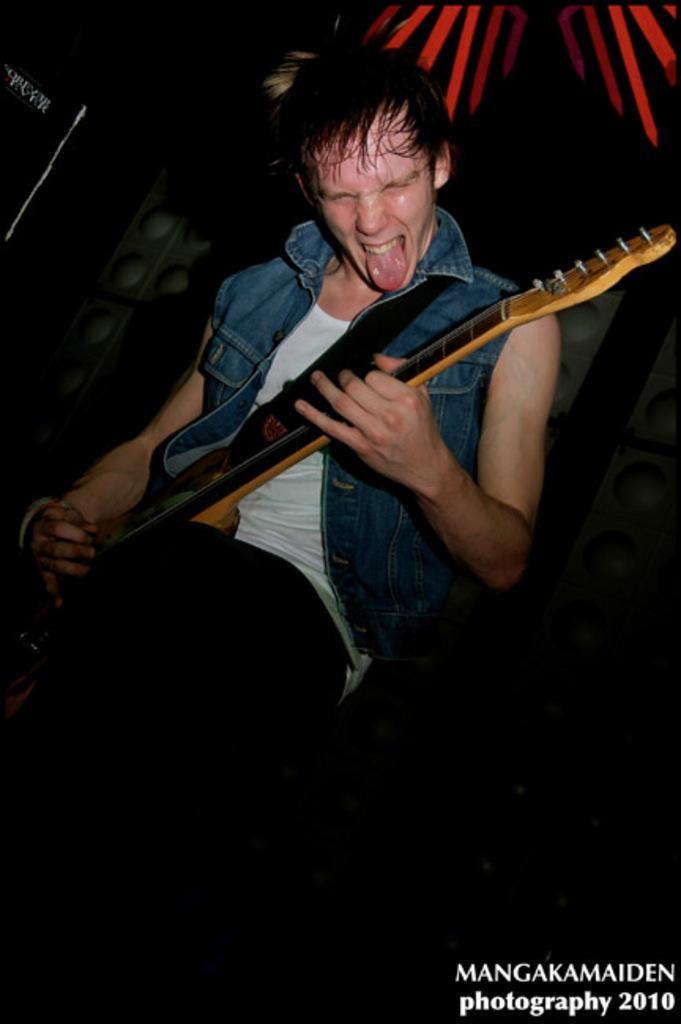Please provide a concise description of this image. In this picture we can see a man who is playing a guitar. 